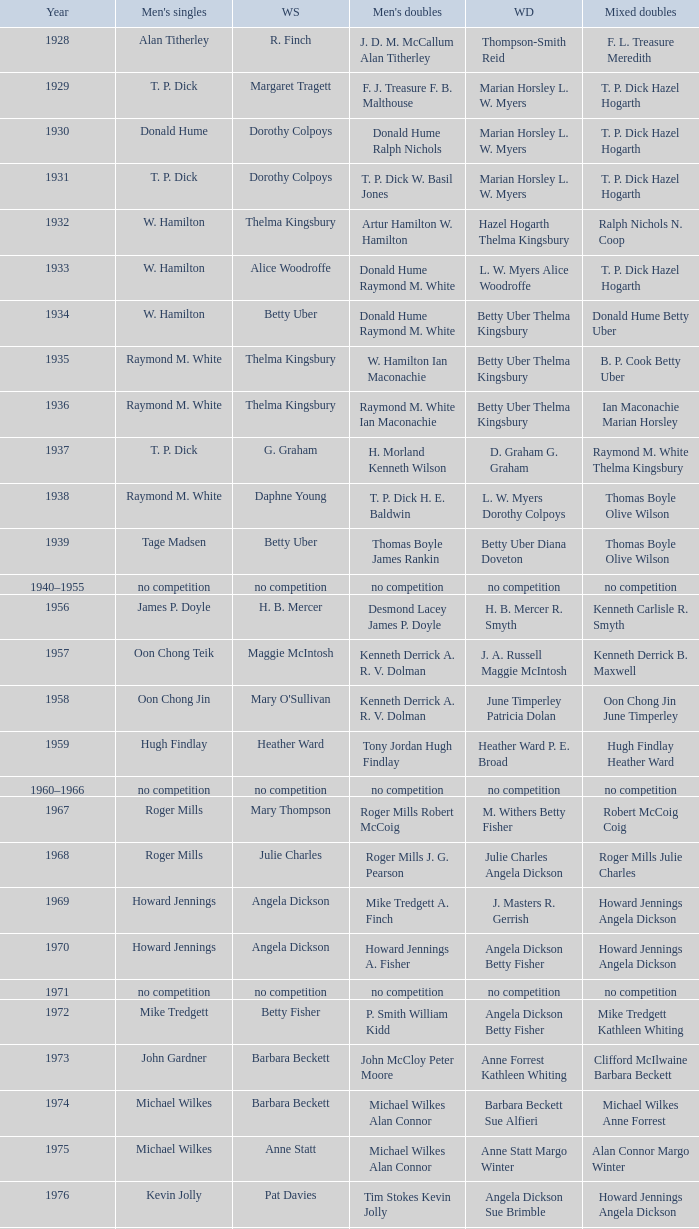Who won the Women's singles, in the year that Raymond M. White won the Men's singles and that W. Hamilton Ian Maconachie won the Men's doubles? Thelma Kingsbury. 